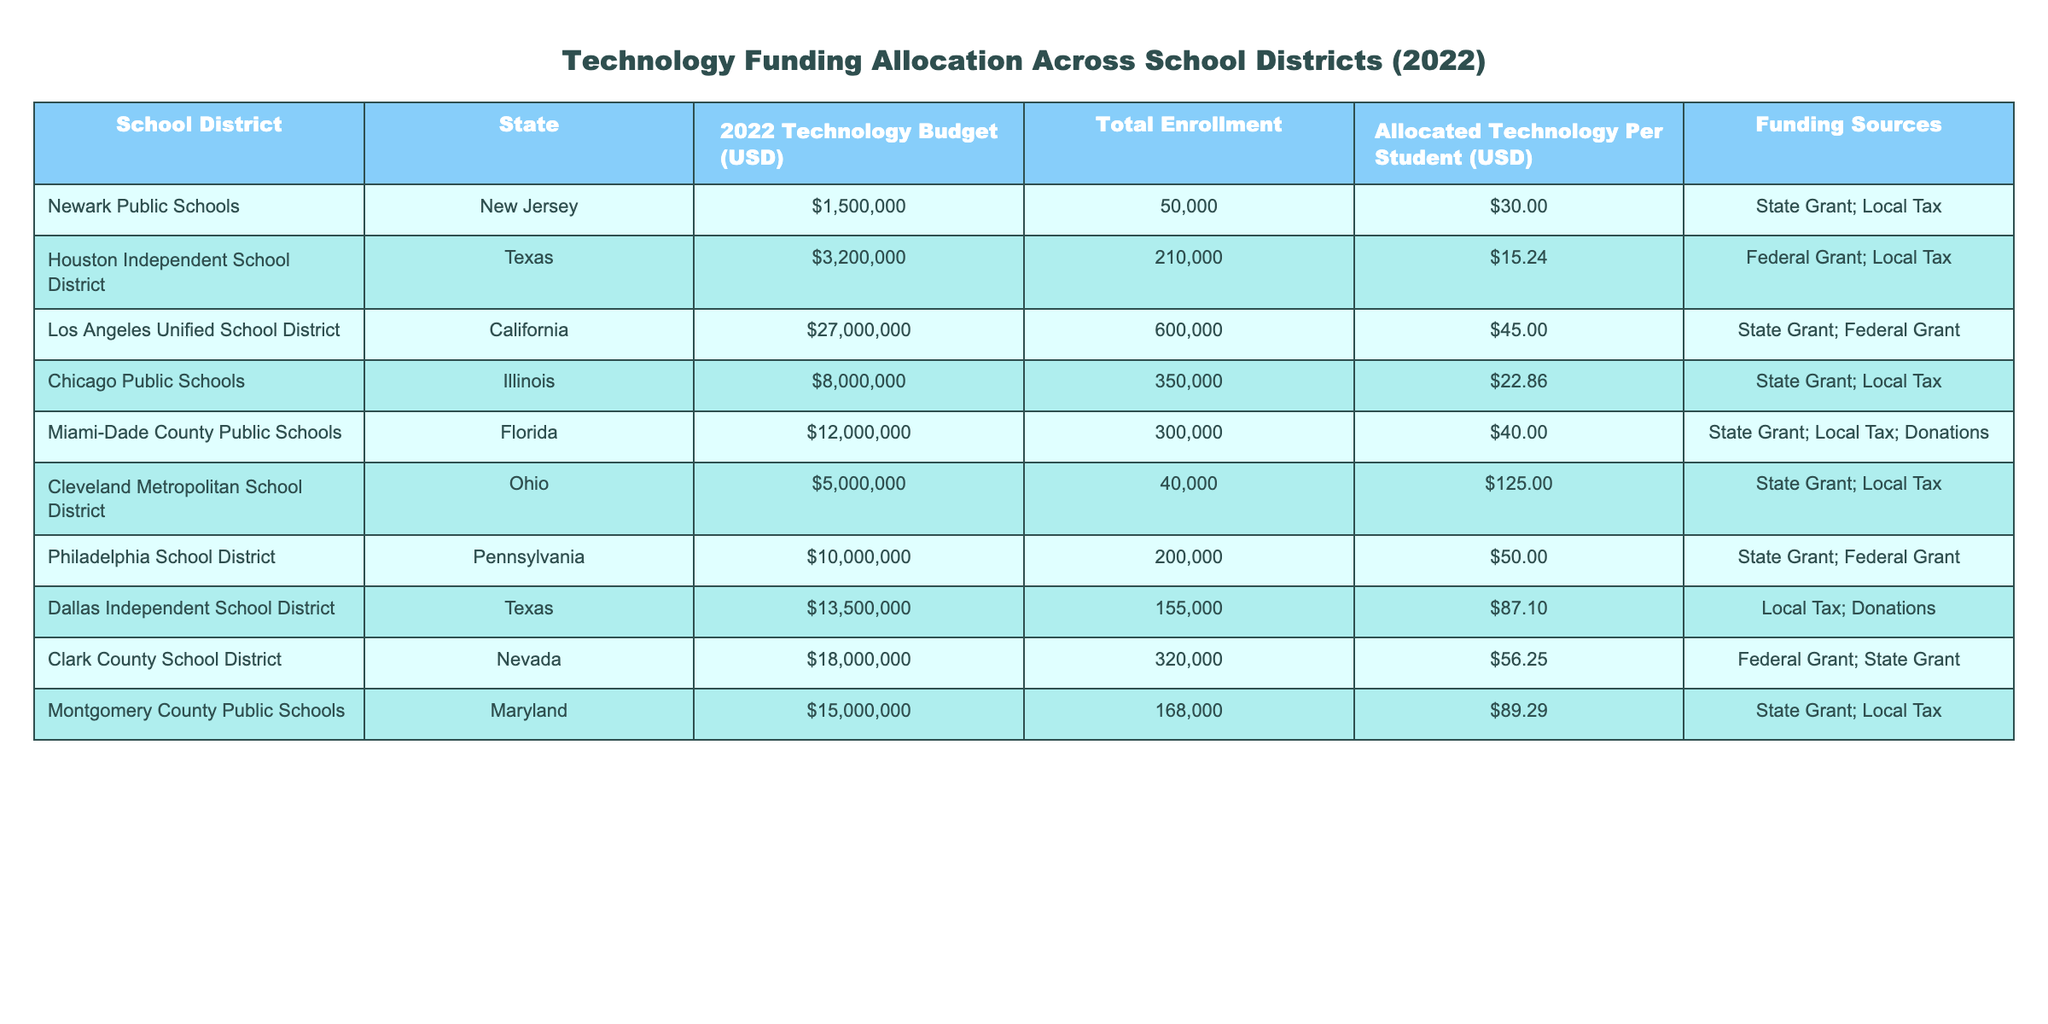What is the total technology budget allocated for the Newark Public Schools? The value in the "2022 Technology Budget (USD)" column for Newark Public Schools is 1,500,000.
Answer: 1,500,000 Which school district has the highest technology budget? Looking at the "2022 Technology Budget (USD)" column, Los Angeles Unified School District has the highest budget of 27,000,000.
Answer: Los Angeles Unified School District What is the allocated technology per student for the Miami-Dade County Public Schools? The allocated technology per student for Miami-Dade County Public Schools is 40, as seen in the "Allocated Technology Per Student (USD)" column.
Answer: 40 How many total students are enrolled in the Philadelphia School District? The total enrollment for Philadelphia School District is 200,000, as indicated in the "Total Enrollment" column.
Answer: 200,000 Which district has the lowest allocated technology per student, and what is that amount? Houston Independent School District has the lowest allocated technology per student at 15.24, based on the figures in the "Allocated Technology Per Student (USD)" column.
Answer: Houston Independent School District, 15.24 What is the average allocated technology per student across all listed school districts? The sum of the allocated technology per student across districts is 30 + 15.24 + 45 + 22.86 + 40 + 125 + 50 + 87.10 + 56.25 + 89.29 = 419.74. As there are 10 districts, the average is 419.74/10 = 41.974.
Answer: 41.97 Are there any school districts funded entirely through local taxes? By examining the "Funding Sources" column, there are no school districts funded entirely by local taxes; all have at least one other source of funding.
Answer: No Which state has the highest total technology budget in this table? By comparing the budgets, California has the highest technology budget with 27,000,000 from Los Angeles Unified School District.
Answer: California What is the total technology budget of all school districts from Texas? The budgets for the Texas school districts are Houston Independent School District (3,200,000) and Dallas Independent School District (13,500,000). The total is 3,200,000 + 13,500,000 = 16,700,000.
Answer: 16,700,000 How does the allocated technology per student differ between Philadelphia School District and Chicago Public Schools? Philadelphia School District has an allocated technology per student of 50, while Chicago Public Schools has 22.86. The difference is 50 - 22.86 = 27.14.
Answer: 27.14 Which funding sources are used by Montgomery County Public Schools? The "Funding Sources" for Montgomery County Public Schools include State Grant and Local Tax, as specified in the table.
Answer: State Grant; Local Tax 